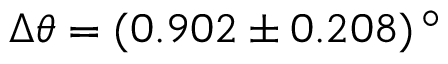<formula> <loc_0><loc_0><loc_500><loc_500>\Delta \theta = ( 0 . 9 0 2 \pm 0 . 2 0 8 ) \, ^ { \circ }</formula> 